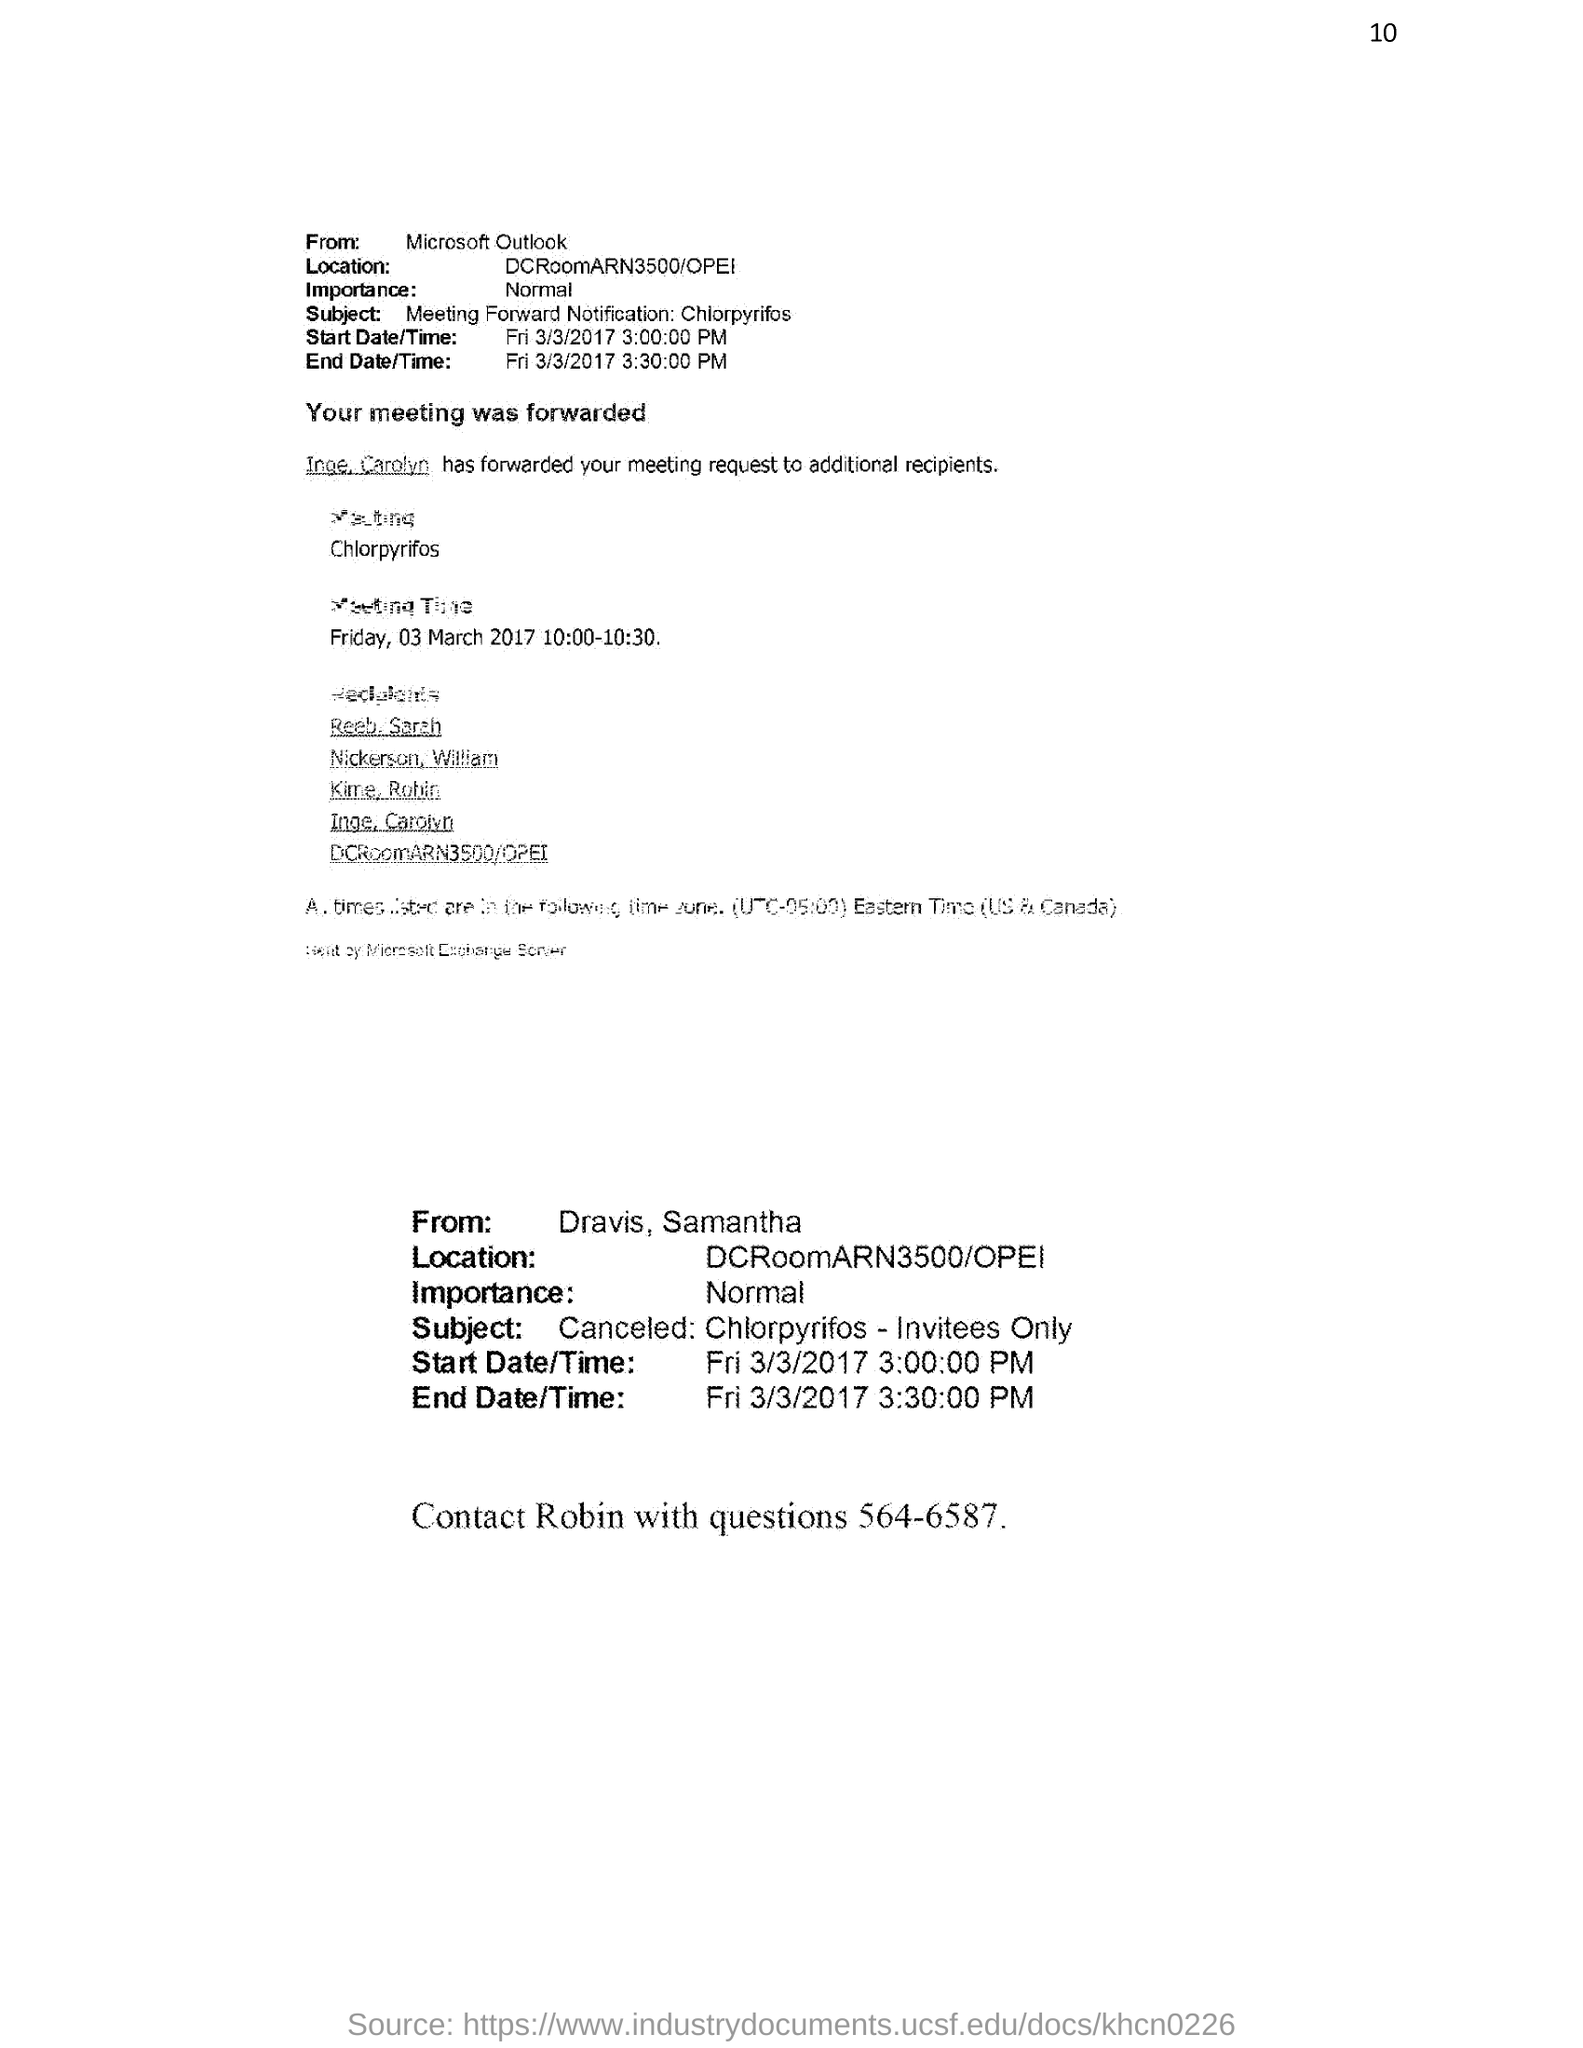List a handful of essential elements in this visual. The end time of the meeting is 3:30:00 PM. The importance level of the email is normal. The start time of the meeting is 3:00:00 PM. I seek the contact information for Robin, specifically their phone number, which is 564-6587... 